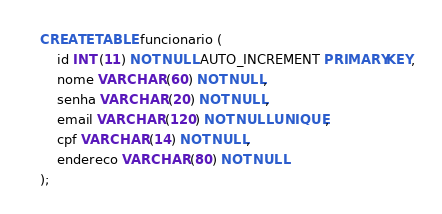<code> <loc_0><loc_0><loc_500><loc_500><_SQL_>CREATE TABLE funcionario (
    id INT (11) NOT NULL AUTO_INCREMENT PRIMARY KEY,
    nome VARCHAR (60) NOT NULL,
    senha VARCHAR (20) NOT NULL,
    email VARCHAR (120) NOT NULL UNIQUE,
    cpf VARCHAR (14) NOT NULL,
    endereco VARCHAR (80) NOT NULL
);
</code> 